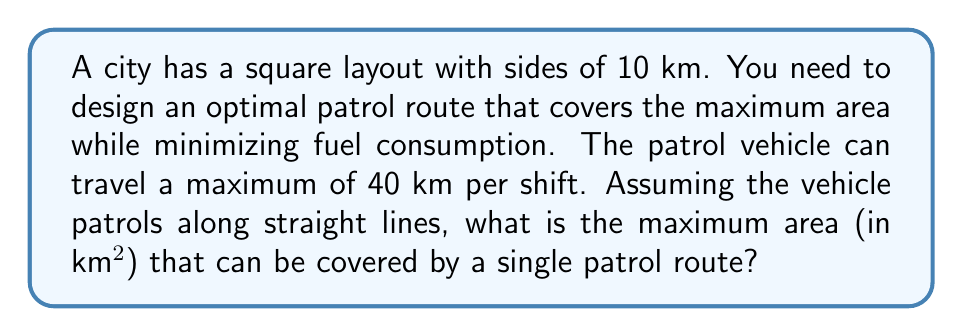Could you help me with this problem? Let's approach this step-by-step:

1) The city is a square with sides of 10 km, so its total area is 100 km².

2) To maximize the covered area, we need to create a route that divides the city into equal strips.

3) Let's say the width of each strip is $x$ km.

4) The number of strips will be $\frac{10}{x}$.

5) The length of the patrol route will be:
   $$L = 10 \cdot \frac{10}{x} = \frac{100}{x}$$

6) We know that the maximum distance the vehicle can travel is 40 km, so:
   $$\frac{100}{x} = 40$$

7) Solving for $x$:
   $$x = \frac{100}{40} = 2.5 \text{ km}$$

8) This means the optimal route will create strips that are 2.5 km wide.

9) The area covered by the patrol can be visualized as follows:

[asy]
size(200);
draw((0,0)--(100,0)--(100,100)--(0,100)--cycle);
for(int i=0; i<=4; ++i) {
  draw((0,i*25)--(100,i*25),dashed);
}
label("10 km", (50,100), N);
label("10 km", (100,50), E);
label("2.5 km", (0,12.5), W);
[/asy]

10) The vehicle will pass through the center of each strip, effectively covering 1.25 km on each side.

11) The total width covered is:
    $$4 \cdot 2.5 = 10 \text{ km}$$

12) Therefore, the area covered is:
    $$10 \text{ km} \cdot 10 \text{ km} = 100 \text{ km}^2$$

13) The patrol route covers the entire city area.
Answer: 100 km² 